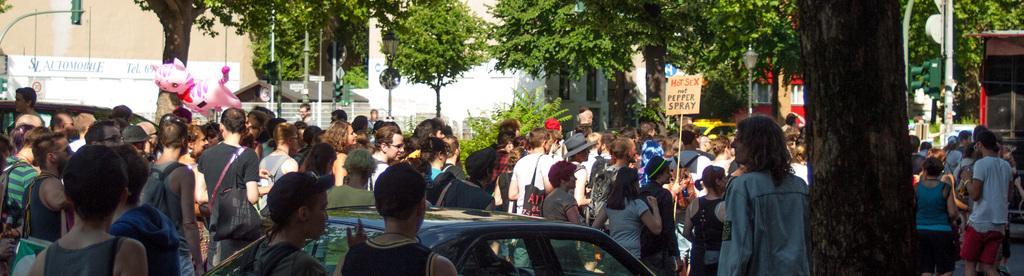In one or two sentences, can you explain what this image depicts? At the bottom of this image, there are persons in different color dresses, a vehicle and a tree. In the background, there are trees, plants, buildings and poles. 